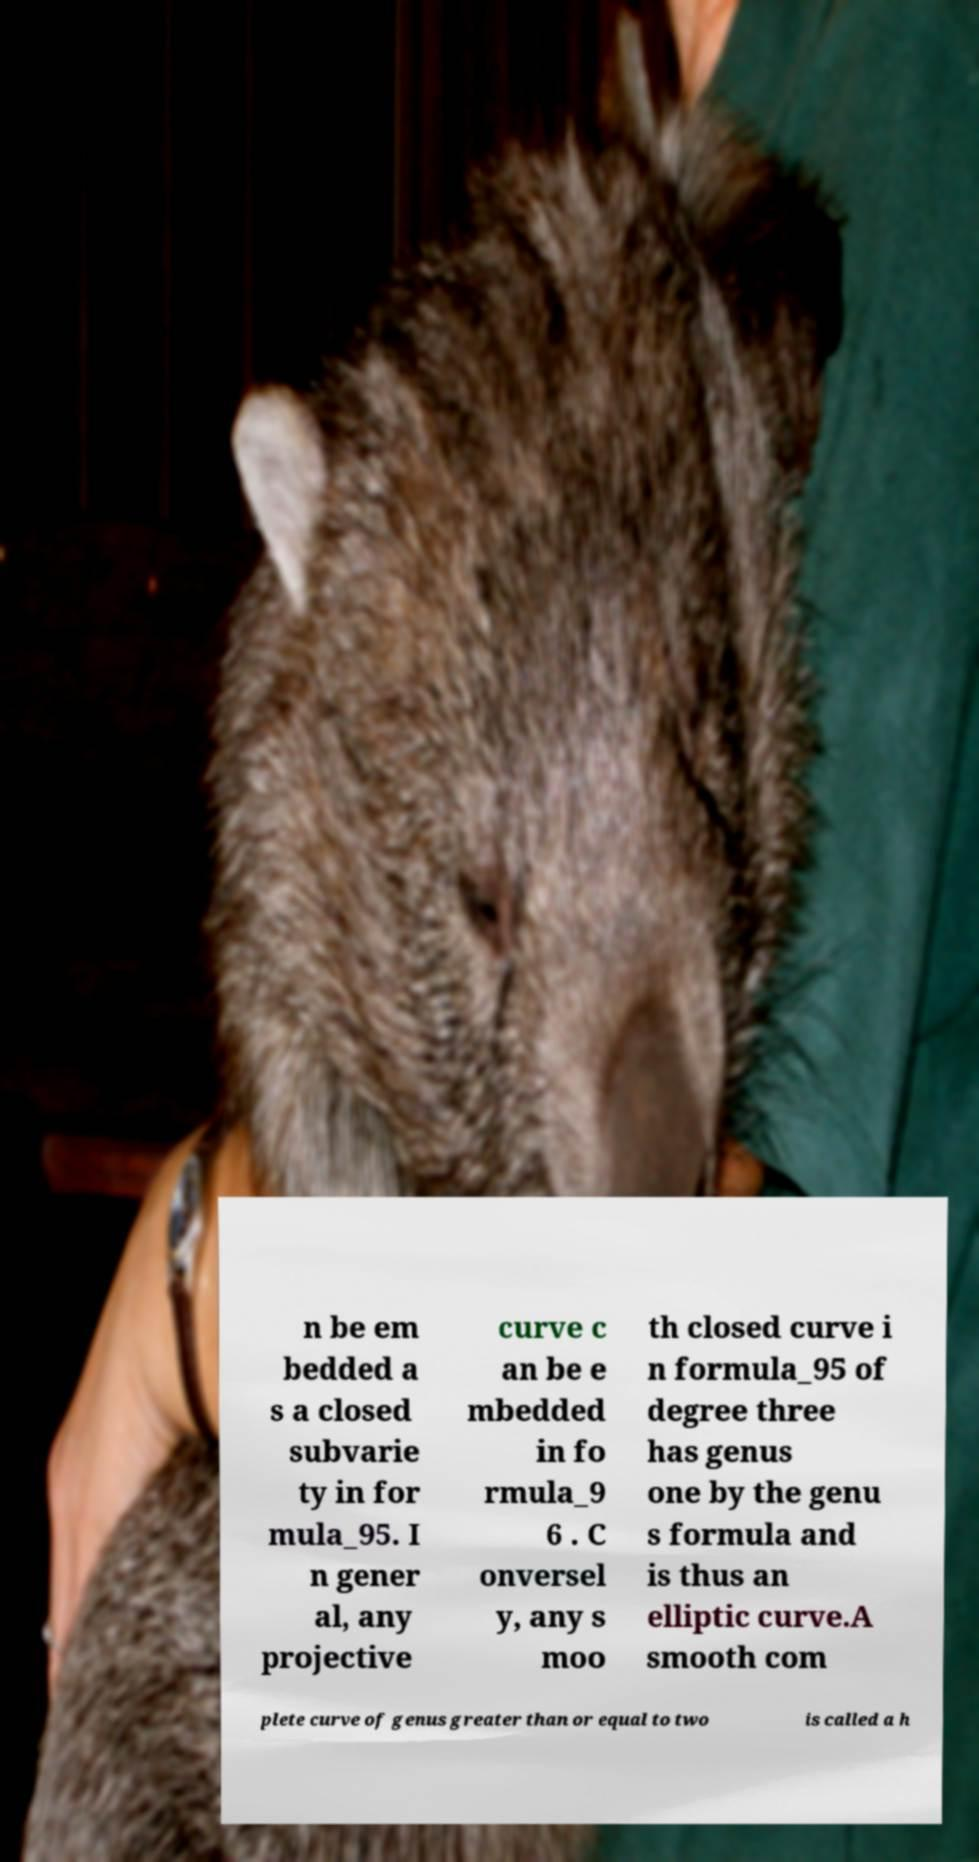Please read and relay the text visible in this image. What does it say? n be em bedded a s a closed subvarie ty in for mula_95. I n gener al, any projective curve c an be e mbedded in fo rmula_9 6 . C onversel y, any s moo th closed curve i n formula_95 of degree three has genus one by the genu s formula and is thus an elliptic curve.A smooth com plete curve of genus greater than or equal to two is called a h 